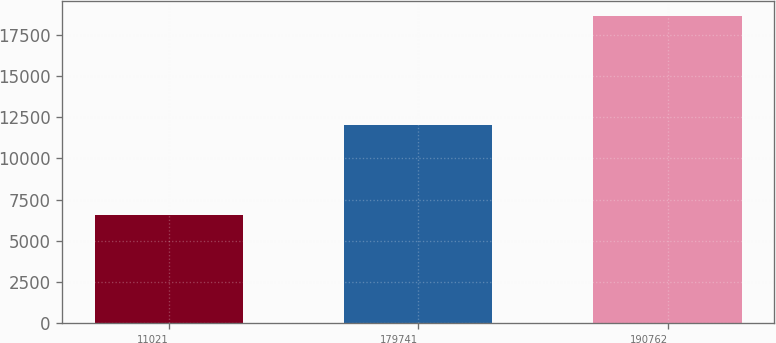<chart> <loc_0><loc_0><loc_500><loc_500><bar_chart><fcel>11021<fcel>179741<fcel>190762<nl><fcel>6577<fcel>12041<fcel>18618<nl></chart> 